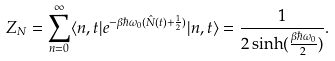Convert formula to latex. <formula><loc_0><loc_0><loc_500><loc_500>Z _ { N } = \sum _ { n = 0 } ^ { \infty } \langle n , t | e ^ { - \beta \hbar { \omega } _ { 0 } ( \hat { N } ( t ) + \frac { 1 } { 2 } ) } | n , t \rangle = \frac { 1 } { 2 \sinh ( \frac { \beta \hbar { \omega } _ { 0 } } { 2 } ) } .</formula> 